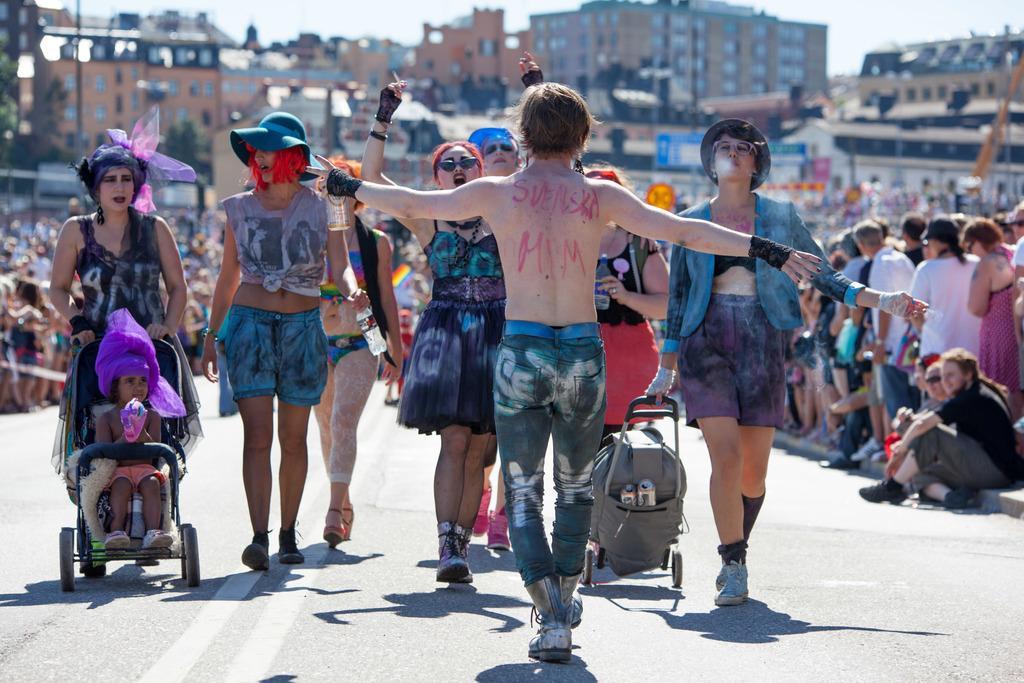Describe this image in one or two sentences. In this image there is a road. There are people walking. There are other people standing on the both sides. There are trees. There are many buildings in the background. There is a sky. 